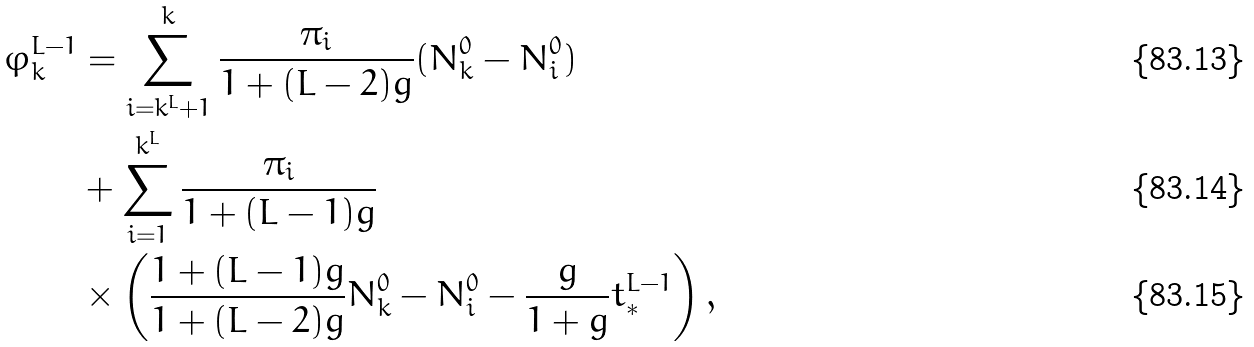<formula> <loc_0><loc_0><loc_500><loc_500>\varphi ^ { L - 1 } _ { k } & = \sum _ { i = k ^ { L } + 1 } ^ { k } \frac { \pi _ { i } } { 1 + ( L - 2 ) g } ( N ^ { 0 } _ { k } - N ^ { 0 } _ { i } ) \\ & + \sum _ { i = 1 } ^ { k ^ { L } } \frac { \pi _ { i } } { 1 + ( L - 1 ) g } \\ & \times \left ( \frac { 1 + ( L - 1 ) g } { 1 + ( L - 2 ) g } N ^ { 0 } _ { k } - N ^ { 0 } _ { i } - \frac { g } { 1 + g } t ^ { L - 1 } _ { * } \right ) ,</formula> 